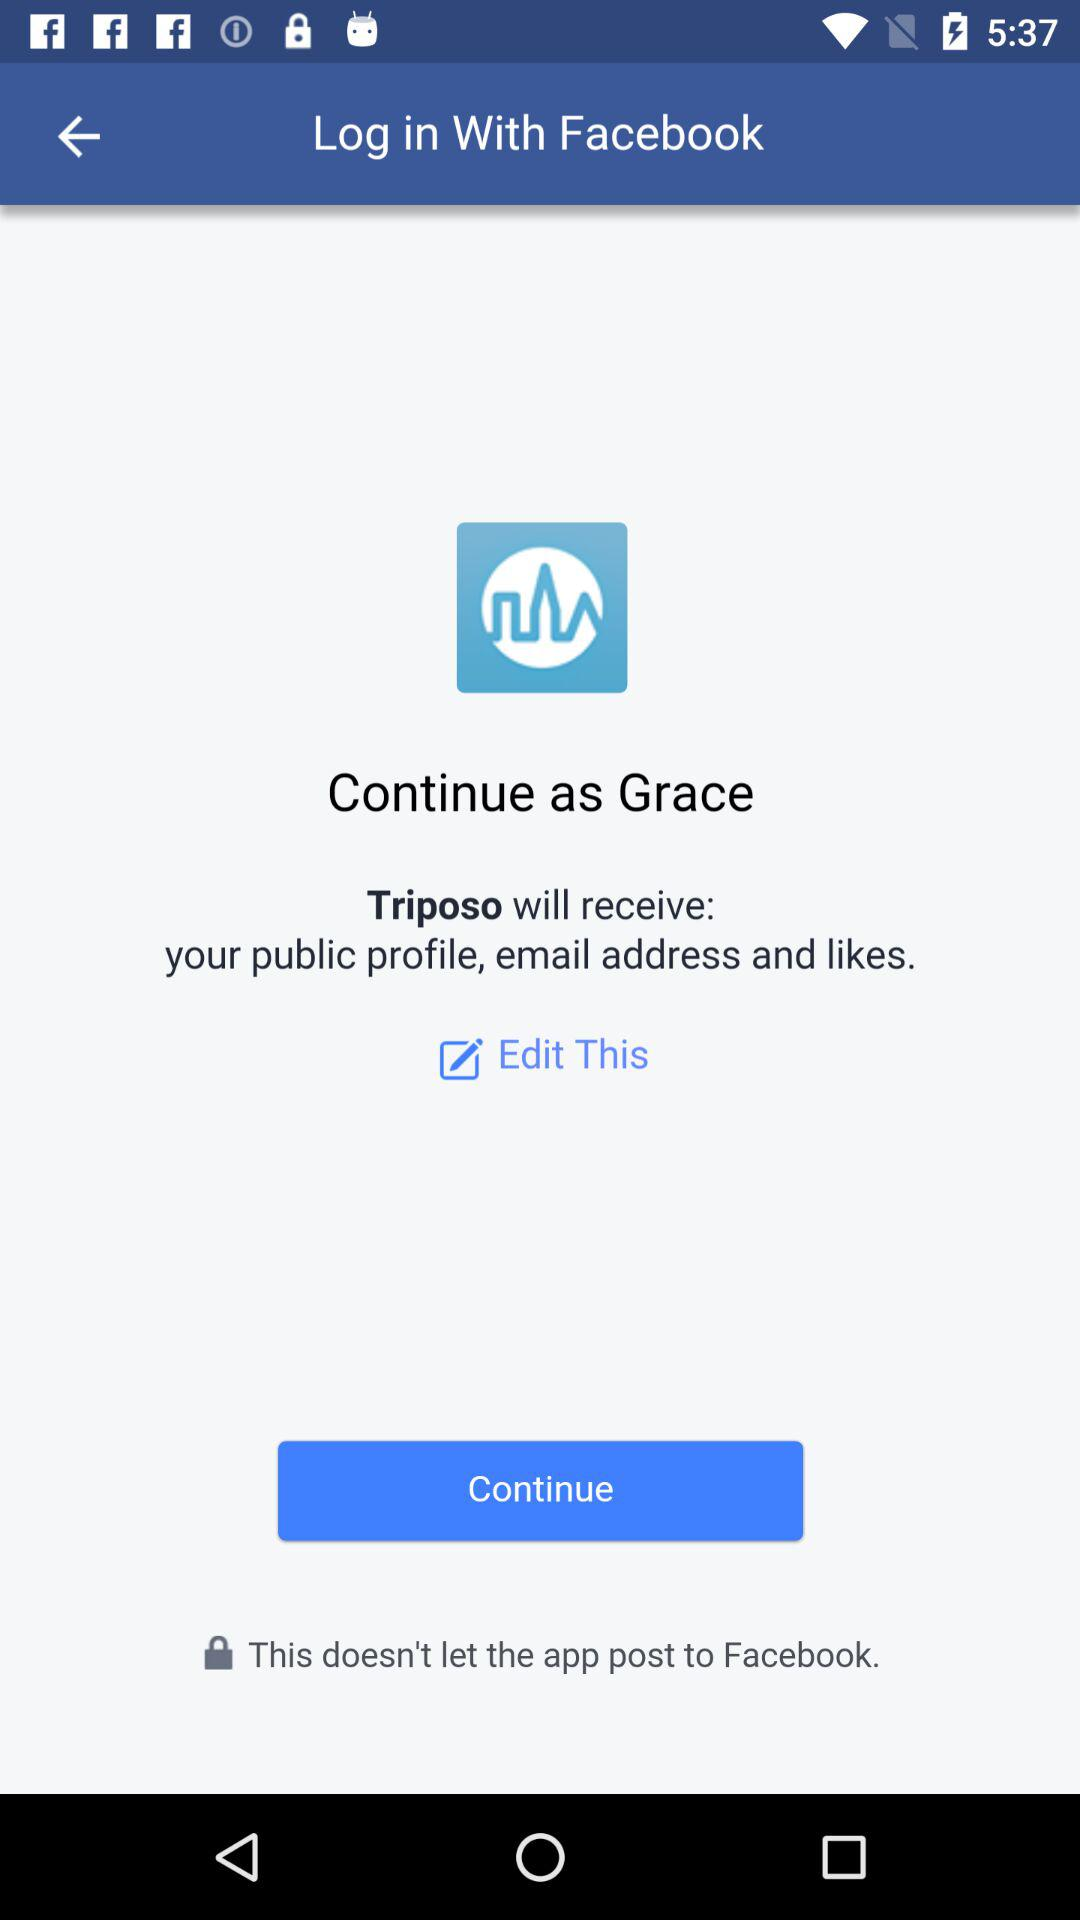Who will receive the public profile, email address, and likes? The public profile, email address, and likes will be received by "Triposo". 